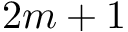<formula> <loc_0><loc_0><loc_500><loc_500>2 m + 1</formula> 